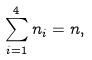<formula> <loc_0><loc_0><loc_500><loc_500>\sum _ { i = 1 } ^ { 4 } n _ { i } = n ,</formula> 